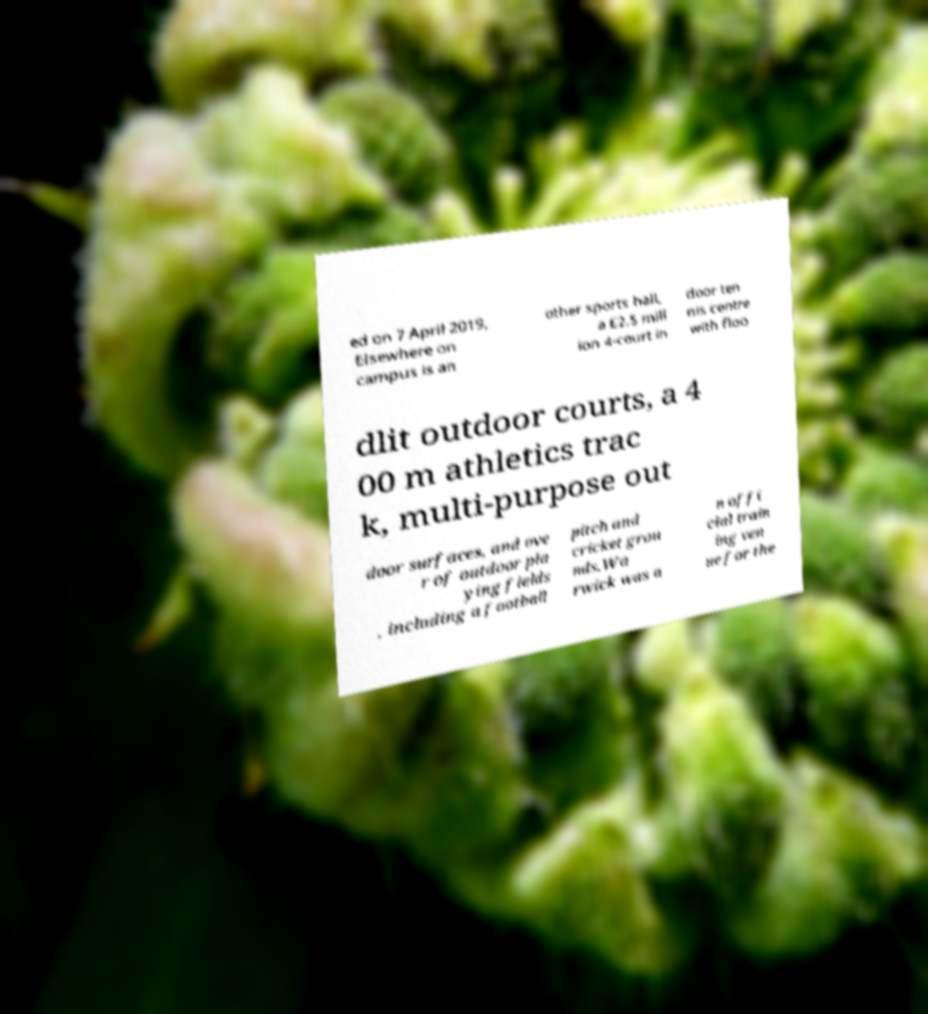For documentation purposes, I need the text within this image transcribed. Could you provide that? ed on 7 April 2019, Elsewhere on campus is an other sports hall, a £2.5 mill ion 4-court in door ten nis centre with floo dlit outdoor courts, a 4 00 m athletics trac k, multi-purpose out door surfaces, and ove r of outdoor pla ying fields , including a football pitch and cricket grou nds.Wa rwick was a n offi cial train ing ven ue for the 